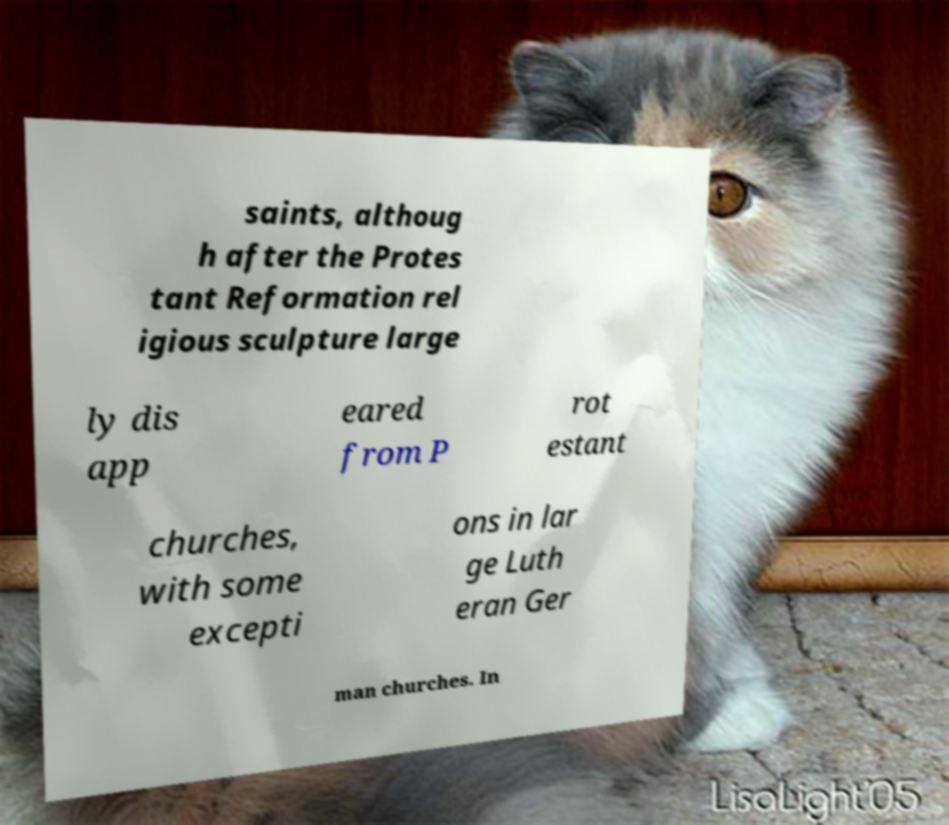Could you assist in decoding the text presented in this image and type it out clearly? saints, althoug h after the Protes tant Reformation rel igious sculpture large ly dis app eared from P rot estant churches, with some excepti ons in lar ge Luth eran Ger man churches. In 